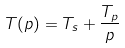<formula> <loc_0><loc_0><loc_500><loc_500>T ( p ) = T _ { s } + \frac { T _ { p } } { p }</formula> 